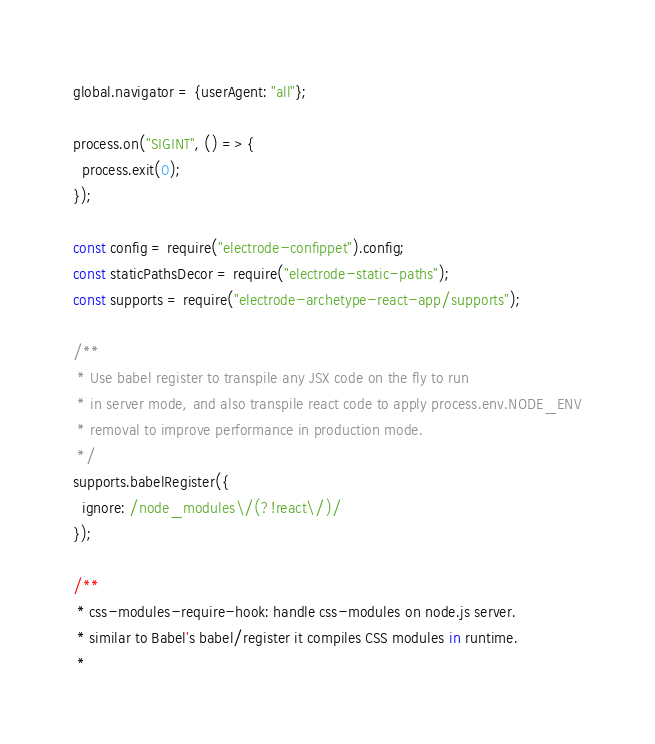Convert code to text. <code><loc_0><loc_0><loc_500><loc_500><_JavaScript_>global.navigator = {userAgent: "all"};

process.on("SIGINT", () => {
  process.exit(0);
});

const config = require("electrode-confippet").config;
const staticPathsDecor = require("electrode-static-paths");
const supports = require("electrode-archetype-react-app/supports");

/**
 * Use babel register to transpile any JSX code on the fly to run
 * in server mode, and also transpile react code to apply process.env.NODE_ENV
 * removal to improve performance in production mode.
 */
supports.babelRegister({
  ignore: /node_modules\/(?!react\/)/
});

/**
 * css-modules-require-hook: handle css-modules on node.js server.
 * similar to Babel's babel/register it compiles CSS modules in runtime.
 *</code> 